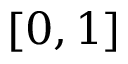<formula> <loc_0><loc_0><loc_500><loc_500>[ 0 , 1 ]</formula> 